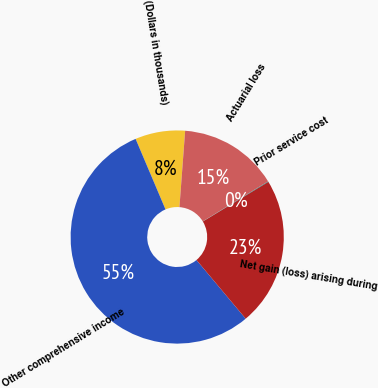<chart> <loc_0><loc_0><loc_500><loc_500><pie_chart><fcel>(Dollars in thousands)<fcel>Other comprehensive income<fcel>Net gain (loss) arising during<fcel>Prior service cost<fcel>Actuarial loss<nl><fcel>7.57%<fcel>54.73%<fcel>22.56%<fcel>0.08%<fcel>15.07%<nl></chart> 